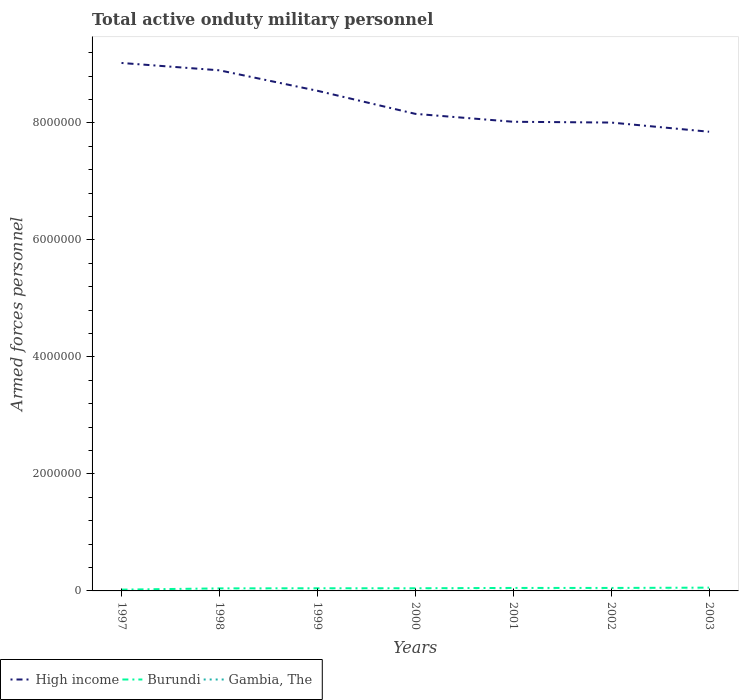How many different coloured lines are there?
Your response must be concise. 3. Does the line corresponding to Gambia, The intersect with the line corresponding to Burundi?
Give a very brief answer. No. Across all years, what is the maximum number of armed forces personnel in Gambia, The?
Offer a very short reply. 800. What is the total number of armed forces personnel in Burundi in the graph?
Give a very brief answer. -3.40e+04. What is the difference between the highest and the second highest number of armed forces personnel in Gambia, The?
Offer a terse response. 0. How many lines are there?
Provide a short and direct response. 3. How many years are there in the graph?
Give a very brief answer. 7. How many legend labels are there?
Your answer should be compact. 3. How are the legend labels stacked?
Your answer should be very brief. Horizontal. What is the title of the graph?
Offer a very short reply. Total active onduty military personnel. Does "Venezuela" appear as one of the legend labels in the graph?
Your response must be concise. No. What is the label or title of the Y-axis?
Give a very brief answer. Armed forces personnel. What is the Armed forces personnel in High income in 1997?
Make the answer very short. 9.03e+06. What is the Armed forces personnel in Burundi in 1997?
Your answer should be compact. 2.20e+04. What is the Armed forces personnel in Gambia, The in 1997?
Make the answer very short. 800. What is the Armed forces personnel of High income in 1998?
Provide a short and direct response. 8.90e+06. What is the Armed forces personnel of Burundi in 1998?
Your response must be concise. 4.35e+04. What is the Armed forces personnel of Gambia, The in 1998?
Give a very brief answer. 800. What is the Armed forces personnel in High income in 1999?
Your answer should be very brief. 8.55e+06. What is the Armed forces personnel in Burundi in 1999?
Offer a terse response. 4.55e+04. What is the Armed forces personnel of Gambia, The in 1999?
Your answer should be very brief. 800. What is the Armed forces personnel of High income in 2000?
Ensure brevity in your answer.  8.16e+06. What is the Armed forces personnel in Burundi in 2000?
Your answer should be compact. 4.55e+04. What is the Armed forces personnel of Gambia, The in 2000?
Your response must be concise. 800. What is the Armed forces personnel of High income in 2001?
Your answer should be compact. 8.02e+06. What is the Armed forces personnel of Burundi in 2001?
Offer a very short reply. 5.10e+04. What is the Armed forces personnel in Gambia, The in 2001?
Your answer should be very brief. 800. What is the Armed forces personnel of High income in 2002?
Make the answer very short. 8.01e+06. What is the Armed forces personnel in Burundi in 2002?
Your answer should be compact. 5.10e+04. What is the Armed forces personnel in Gambia, The in 2002?
Your response must be concise. 800. What is the Armed forces personnel of High income in 2003?
Keep it short and to the point. 7.85e+06. What is the Armed forces personnel in Burundi in 2003?
Keep it short and to the point. 5.60e+04. What is the Armed forces personnel of Gambia, The in 2003?
Your response must be concise. 800. Across all years, what is the maximum Armed forces personnel of High income?
Offer a very short reply. 9.03e+06. Across all years, what is the maximum Armed forces personnel of Burundi?
Offer a terse response. 5.60e+04. Across all years, what is the maximum Armed forces personnel of Gambia, The?
Provide a succinct answer. 800. Across all years, what is the minimum Armed forces personnel of High income?
Your answer should be very brief. 7.85e+06. Across all years, what is the minimum Armed forces personnel of Burundi?
Keep it short and to the point. 2.20e+04. Across all years, what is the minimum Armed forces personnel of Gambia, The?
Your answer should be very brief. 800. What is the total Armed forces personnel of High income in the graph?
Your answer should be very brief. 5.85e+07. What is the total Armed forces personnel of Burundi in the graph?
Give a very brief answer. 3.14e+05. What is the total Armed forces personnel in Gambia, The in the graph?
Offer a very short reply. 5600. What is the difference between the Armed forces personnel of High income in 1997 and that in 1998?
Make the answer very short. 1.26e+05. What is the difference between the Armed forces personnel in Burundi in 1997 and that in 1998?
Make the answer very short. -2.15e+04. What is the difference between the Armed forces personnel in Gambia, The in 1997 and that in 1998?
Offer a very short reply. 0. What is the difference between the Armed forces personnel in High income in 1997 and that in 1999?
Your response must be concise. 4.75e+05. What is the difference between the Armed forces personnel in Burundi in 1997 and that in 1999?
Offer a terse response. -2.35e+04. What is the difference between the Armed forces personnel of High income in 1997 and that in 2000?
Your answer should be compact. 8.70e+05. What is the difference between the Armed forces personnel of Burundi in 1997 and that in 2000?
Ensure brevity in your answer.  -2.35e+04. What is the difference between the Armed forces personnel of Gambia, The in 1997 and that in 2000?
Keep it short and to the point. 0. What is the difference between the Armed forces personnel of High income in 1997 and that in 2001?
Your response must be concise. 1.01e+06. What is the difference between the Armed forces personnel of Burundi in 1997 and that in 2001?
Ensure brevity in your answer.  -2.90e+04. What is the difference between the Armed forces personnel in Gambia, The in 1997 and that in 2001?
Make the answer very short. 0. What is the difference between the Armed forces personnel of High income in 1997 and that in 2002?
Provide a succinct answer. 1.02e+06. What is the difference between the Armed forces personnel of Burundi in 1997 and that in 2002?
Provide a succinct answer. -2.90e+04. What is the difference between the Armed forces personnel of High income in 1997 and that in 2003?
Offer a terse response. 1.18e+06. What is the difference between the Armed forces personnel in Burundi in 1997 and that in 2003?
Your answer should be compact. -3.40e+04. What is the difference between the Armed forces personnel in High income in 1998 and that in 1999?
Ensure brevity in your answer.  3.50e+05. What is the difference between the Armed forces personnel in Burundi in 1998 and that in 1999?
Provide a short and direct response. -2000. What is the difference between the Armed forces personnel of High income in 1998 and that in 2000?
Ensure brevity in your answer.  7.44e+05. What is the difference between the Armed forces personnel in Burundi in 1998 and that in 2000?
Your response must be concise. -2000. What is the difference between the Armed forces personnel of High income in 1998 and that in 2001?
Give a very brief answer. 8.79e+05. What is the difference between the Armed forces personnel in Burundi in 1998 and that in 2001?
Offer a very short reply. -7500. What is the difference between the Armed forces personnel in Gambia, The in 1998 and that in 2001?
Offer a very short reply. 0. What is the difference between the Armed forces personnel of High income in 1998 and that in 2002?
Offer a terse response. 8.93e+05. What is the difference between the Armed forces personnel of Burundi in 1998 and that in 2002?
Give a very brief answer. -7500. What is the difference between the Armed forces personnel of High income in 1998 and that in 2003?
Give a very brief answer. 1.05e+06. What is the difference between the Armed forces personnel in Burundi in 1998 and that in 2003?
Provide a succinct answer. -1.25e+04. What is the difference between the Armed forces personnel in High income in 1999 and that in 2000?
Keep it short and to the point. 3.95e+05. What is the difference between the Armed forces personnel in Burundi in 1999 and that in 2000?
Make the answer very short. 0. What is the difference between the Armed forces personnel of Gambia, The in 1999 and that in 2000?
Offer a very short reply. 0. What is the difference between the Armed forces personnel of High income in 1999 and that in 2001?
Your answer should be compact. 5.30e+05. What is the difference between the Armed forces personnel of Burundi in 1999 and that in 2001?
Offer a very short reply. -5500. What is the difference between the Armed forces personnel in High income in 1999 and that in 2002?
Your answer should be compact. 5.43e+05. What is the difference between the Armed forces personnel of Burundi in 1999 and that in 2002?
Offer a very short reply. -5500. What is the difference between the Armed forces personnel in High income in 1999 and that in 2003?
Give a very brief answer. 7.00e+05. What is the difference between the Armed forces personnel of Burundi in 1999 and that in 2003?
Offer a very short reply. -1.05e+04. What is the difference between the Armed forces personnel in Gambia, The in 1999 and that in 2003?
Offer a terse response. 0. What is the difference between the Armed forces personnel of High income in 2000 and that in 2001?
Keep it short and to the point. 1.35e+05. What is the difference between the Armed forces personnel in Burundi in 2000 and that in 2001?
Make the answer very short. -5500. What is the difference between the Armed forces personnel in High income in 2000 and that in 2002?
Your response must be concise. 1.49e+05. What is the difference between the Armed forces personnel of Burundi in 2000 and that in 2002?
Give a very brief answer. -5500. What is the difference between the Armed forces personnel in Gambia, The in 2000 and that in 2002?
Offer a very short reply. 0. What is the difference between the Armed forces personnel in High income in 2000 and that in 2003?
Give a very brief answer. 3.06e+05. What is the difference between the Armed forces personnel of Burundi in 2000 and that in 2003?
Your answer should be very brief. -1.05e+04. What is the difference between the Armed forces personnel of Gambia, The in 2000 and that in 2003?
Keep it short and to the point. 0. What is the difference between the Armed forces personnel in High income in 2001 and that in 2002?
Provide a succinct answer. 1.36e+04. What is the difference between the Armed forces personnel in Burundi in 2001 and that in 2002?
Provide a succinct answer. 0. What is the difference between the Armed forces personnel of Gambia, The in 2001 and that in 2002?
Offer a very short reply. 0. What is the difference between the Armed forces personnel in High income in 2001 and that in 2003?
Ensure brevity in your answer.  1.70e+05. What is the difference between the Armed forces personnel of Burundi in 2001 and that in 2003?
Your answer should be compact. -5000. What is the difference between the Armed forces personnel of High income in 2002 and that in 2003?
Your response must be concise. 1.57e+05. What is the difference between the Armed forces personnel of Burundi in 2002 and that in 2003?
Your answer should be very brief. -5000. What is the difference between the Armed forces personnel of Gambia, The in 2002 and that in 2003?
Your answer should be very brief. 0. What is the difference between the Armed forces personnel in High income in 1997 and the Armed forces personnel in Burundi in 1998?
Your answer should be compact. 8.98e+06. What is the difference between the Armed forces personnel of High income in 1997 and the Armed forces personnel of Gambia, The in 1998?
Ensure brevity in your answer.  9.02e+06. What is the difference between the Armed forces personnel in Burundi in 1997 and the Armed forces personnel in Gambia, The in 1998?
Make the answer very short. 2.12e+04. What is the difference between the Armed forces personnel in High income in 1997 and the Armed forces personnel in Burundi in 1999?
Your response must be concise. 8.98e+06. What is the difference between the Armed forces personnel in High income in 1997 and the Armed forces personnel in Gambia, The in 1999?
Your answer should be compact. 9.02e+06. What is the difference between the Armed forces personnel in Burundi in 1997 and the Armed forces personnel in Gambia, The in 1999?
Offer a terse response. 2.12e+04. What is the difference between the Armed forces personnel in High income in 1997 and the Armed forces personnel in Burundi in 2000?
Give a very brief answer. 8.98e+06. What is the difference between the Armed forces personnel in High income in 1997 and the Armed forces personnel in Gambia, The in 2000?
Offer a terse response. 9.02e+06. What is the difference between the Armed forces personnel in Burundi in 1997 and the Armed forces personnel in Gambia, The in 2000?
Offer a very short reply. 2.12e+04. What is the difference between the Armed forces personnel in High income in 1997 and the Armed forces personnel in Burundi in 2001?
Keep it short and to the point. 8.97e+06. What is the difference between the Armed forces personnel of High income in 1997 and the Armed forces personnel of Gambia, The in 2001?
Your answer should be very brief. 9.02e+06. What is the difference between the Armed forces personnel in Burundi in 1997 and the Armed forces personnel in Gambia, The in 2001?
Give a very brief answer. 2.12e+04. What is the difference between the Armed forces personnel of High income in 1997 and the Armed forces personnel of Burundi in 2002?
Provide a succinct answer. 8.97e+06. What is the difference between the Armed forces personnel of High income in 1997 and the Armed forces personnel of Gambia, The in 2002?
Ensure brevity in your answer.  9.02e+06. What is the difference between the Armed forces personnel of Burundi in 1997 and the Armed forces personnel of Gambia, The in 2002?
Your answer should be compact. 2.12e+04. What is the difference between the Armed forces personnel of High income in 1997 and the Armed forces personnel of Burundi in 2003?
Ensure brevity in your answer.  8.97e+06. What is the difference between the Armed forces personnel in High income in 1997 and the Armed forces personnel in Gambia, The in 2003?
Give a very brief answer. 9.02e+06. What is the difference between the Armed forces personnel in Burundi in 1997 and the Armed forces personnel in Gambia, The in 2003?
Your answer should be compact. 2.12e+04. What is the difference between the Armed forces personnel of High income in 1998 and the Armed forces personnel of Burundi in 1999?
Keep it short and to the point. 8.85e+06. What is the difference between the Armed forces personnel in High income in 1998 and the Armed forces personnel in Gambia, The in 1999?
Your answer should be compact. 8.90e+06. What is the difference between the Armed forces personnel of Burundi in 1998 and the Armed forces personnel of Gambia, The in 1999?
Make the answer very short. 4.27e+04. What is the difference between the Armed forces personnel of High income in 1998 and the Armed forces personnel of Burundi in 2000?
Provide a short and direct response. 8.85e+06. What is the difference between the Armed forces personnel of High income in 1998 and the Armed forces personnel of Gambia, The in 2000?
Provide a succinct answer. 8.90e+06. What is the difference between the Armed forces personnel in Burundi in 1998 and the Armed forces personnel in Gambia, The in 2000?
Ensure brevity in your answer.  4.27e+04. What is the difference between the Armed forces personnel in High income in 1998 and the Armed forces personnel in Burundi in 2001?
Offer a very short reply. 8.85e+06. What is the difference between the Armed forces personnel in High income in 1998 and the Armed forces personnel in Gambia, The in 2001?
Ensure brevity in your answer.  8.90e+06. What is the difference between the Armed forces personnel in Burundi in 1998 and the Armed forces personnel in Gambia, The in 2001?
Make the answer very short. 4.27e+04. What is the difference between the Armed forces personnel of High income in 1998 and the Armed forces personnel of Burundi in 2002?
Provide a succinct answer. 8.85e+06. What is the difference between the Armed forces personnel of High income in 1998 and the Armed forces personnel of Gambia, The in 2002?
Give a very brief answer. 8.90e+06. What is the difference between the Armed forces personnel in Burundi in 1998 and the Armed forces personnel in Gambia, The in 2002?
Your response must be concise. 4.27e+04. What is the difference between the Armed forces personnel in High income in 1998 and the Armed forces personnel in Burundi in 2003?
Ensure brevity in your answer.  8.84e+06. What is the difference between the Armed forces personnel of High income in 1998 and the Armed forces personnel of Gambia, The in 2003?
Offer a very short reply. 8.90e+06. What is the difference between the Armed forces personnel of Burundi in 1998 and the Armed forces personnel of Gambia, The in 2003?
Give a very brief answer. 4.27e+04. What is the difference between the Armed forces personnel of High income in 1999 and the Armed forces personnel of Burundi in 2000?
Give a very brief answer. 8.50e+06. What is the difference between the Armed forces personnel in High income in 1999 and the Armed forces personnel in Gambia, The in 2000?
Offer a terse response. 8.55e+06. What is the difference between the Armed forces personnel in Burundi in 1999 and the Armed forces personnel in Gambia, The in 2000?
Keep it short and to the point. 4.47e+04. What is the difference between the Armed forces personnel in High income in 1999 and the Armed forces personnel in Burundi in 2001?
Make the answer very short. 8.50e+06. What is the difference between the Armed forces personnel of High income in 1999 and the Armed forces personnel of Gambia, The in 2001?
Your response must be concise. 8.55e+06. What is the difference between the Armed forces personnel in Burundi in 1999 and the Armed forces personnel in Gambia, The in 2001?
Offer a terse response. 4.47e+04. What is the difference between the Armed forces personnel in High income in 1999 and the Armed forces personnel in Burundi in 2002?
Make the answer very short. 8.50e+06. What is the difference between the Armed forces personnel in High income in 1999 and the Armed forces personnel in Gambia, The in 2002?
Your answer should be compact. 8.55e+06. What is the difference between the Armed forces personnel in Burundi in 1999 and the Armed forces personnel in Gambia, The in 2002?
Provide a short and direct response. 4.47e+04. What is the difference between the Armed forces personnel in High income in 1999 and the Armed forces personnel in Burundi in 2003?
Ensure brevity in your answer.  8.49e+06. What is the difference between the Armed forces personnel of High income in 1999 and the Armed forces personnel of Gambia, The in 2003?
Offer a very short reply. 8.55e+06. What is the difference between the Armed forces personnel of Burundi in 1999 and the Armed forces personnel of Gambia, The in 2003?
Keep it short and to the point. 4.47e+04. What is the difference between the Armed forces personnel of High income in 2000 and the Armed forces personnel of Burundi in 2001?
Make the answer very short. 8.10e+06. What is the difference between the Armed forces personnel of High income in 2000 and the Armed forces personnel of Gambia, The in 2001?
Provide a succinct answer. 8.15e+06. What is the difference between the Armed forces personnel in Burundi in 2000 and the Armed forces personnel in Gambia, The in 2001?
Your answer should be compact. 4.47e+04. What is the difference between the Armed forces personnel in High income in 2000 and the Armed forces personnel in Burundi in 2002?
Keep it short and to the point. 8.10e+06. What is the difference between the Armed forces personnel of High income in 2000 and the Armed forces personnel of Gambia, The in 2002?
Provide a short and direct response. 8.15e+06. What is the difference between the Armed forces personnel of Burundi in 2000 and the Armed forces personnel of Gambia, The in 2002?
Your answer should be very brief. 4.47e+04. What is the difference between the Armed forces personnel in High income in 2000 and the Armed forces personnel in Burundi in 2003?
Provide a short and direct response. 8.10e+06. What is the difference between the Armed forces personnel of High income in 2000 and the Armed forces personnel of Gambia, The in 2003?
Your answer should be compact. 8.15e+06. What is the difference between the Armed forces personnel of Burundi in 2000 and the Armed forces personnel of Gambia, The in 2003?
Offer a very short reply. 4.47e+04. What is the difference between the Armed forces personnel of High income in 2001 and the Armed forces personnel of Burundi in 2002?
Your answer should be compact. 7.97e+06. What is the difference between the Armed forces personnel of High income in 2001 and the Armed forces personnel of Gambia, The in 2002?
Offer a very short reply. 8.02e+06. What is the difference between the Armed forces personnel of Burundi in 2001 and the Armed forces personnel of Gambia, The in 2002?
Ensure brevity in your answer.  5.02e+04. What is the difference between the Armed forces personnel in High income in 2001 and the Armed forces personnel in Burundi in 2003?
Provide a succinct answer. 7.96e+06. What is the difference between the Armed forces personnel of High income in 2001 and the Armed forces personnel of Gambia, The in 2003?
Offer a terse response. 8.02e+06. What is the difference between the Armed forces personnel in Burundi in 2001 and the Armed forces personnel in Gambia, The in 2003?
Provide a short and direct response. 5.02e+04. What is the difference between the Armed forces personnel in High income in 2002 and the Armed forces personnel in Burundi in 2003?
Provide a short and direct response. 7.95e+06. What is the difference between the Armed forces personnel in High income in 2002 and the Armed forces personnel in Gambia, The in 2003?
Your answer should be very brief. 8.01e+06. What is the difference between the Armed forces personnel in Burundi in 2002 and the Armed forces personnel in Gambia, The in 2003?
Ensure brevity in your answer.  5.02e+04. What is the average Armed forces personnel in High income per year?
Your answer should be compact. 8.36e+06. What is the average Armed forces personnel in Burundi per year?
Offer a terse response. 4.49e+04. What is the average Armed forces personnel of Gambia, The per year?
Give a very brief answer. 800. In the year 1997, what is the difference between the Armed forces personnel of High income and Armed forces personnel of Burundi?
Provide a succinct answer. 9.00e+06. In the year 1997, what is the difference between the Armed forces personnel of High income and Armed forces personnel of Gambia, The?
Your answer should be compact. 9.02e+06. In the year 1997, what is the difference between the Armed forces personnel of Burundi and Armed forces personnel of Gambia, The?
Your answer should be very brief. 2.12e+04. In the year 1998, what is the difference between the Armed forces personnel of High income and Armed forces personnel of Burundi?
Make the answer very short. 8.86e+06. In the year 1998, what is the difference between the Armed forces personnel in High income and Armed forces personnel in Gambia, The?
Ensure brevity in your answer.  8.90e+06. In the year 1998, what is the difference between the Armed forces personnel in Burundi and Armed forces personnel in Gambia, The?
Ensure brevity in your answer.  4.27e+04. In the year 1999, what is the difference between the Armed forces personnel in High income and Armed forces personnel in Burundi?
Give a very brief answer. 8.50e+06. In the year 1999, what is the difference between the Armed forces personnel of High income and Armed forces personnel of Gambia, The?
Your answer should be compact. 8.55e+06. In the year 1999, what is the difference between the Armed forces personnel in Burundi and Armed forces personnel in Gambia, The?
Offer a terse response. 4.47e+04. In the year 2000, what is the difference between the Armed forces personnel in High income and Armed forces personnel in Burundi?
Make the answer very short. 8.11e+06. In the year 2000, what is the difference between the Armed forces personnel of High income and Armed forces personnel of Gambia, The?
Your answer should be very brief. 8.15e+06. In the year 2000, what is the difference between the Armed forces personnel in Burundi and Armed forces personnel in Gambia, The?
Ensure brevity in your answer.  4.47e+04. In the year 2001, what is the difference between the Armed forces personnel of High income and Armed forces personnel of Burundi?
Offer a terse response. 7.97e+06. In the year 2001, what is the difference between the Armed forces personnel in High income and Armed forces personnel in Gambia, The?
Your response must be concise. 8.02e+06. In the year 2001, what is the difference between the Armed forces personnel of Burundi and Armed forces personnel of Gambia, The?
Your answer should be very brief. 5.02e+04. In the year 2002, what is the difference between the Armed forces personnel in High income and Armed forces personnel in Burundi?
Your answer should be compact. 7.96e+06. In the year 2002, what is the difference between the Armed forces personnel of High income and Armed forces personnel of Gambia, The?
Provide a short and direct response. 8.01e+06. In the year 2002, what is the difference between the Armed forces personnel in Burundi and Armed forces personnel in Gambia, The?
Provide a succinct answer. 5.02e+04. In the year 2003, what is the difference between the Armed forces personnel of High income and Armed forces personnel of Burundi?
Offer a terse response. 7.79e+06. In the year 2003, what is the difference between the Armed forces personnel of High income and Armed forces personnel of Gambia, The?
Keep it short and to the point. 7.85e+06. In the year 2003, what is the difference between the Armed forces personnel in Burundi and Armed forces personnel in Gambia, The?
Make the answer very short. 5.52e+04. What is the ratio of the Armed forces personnel of High income in 1997 to that in 1998?
Offer a terse response. 1.01. What is the ratio of the Armed forces personnel in Burundi in 1997 to that in 1998?
Offer a very short reply. 0.51. What is the ratio of the Armed forces personnel of Gambia, The in 1997 to that in 1998?
Give a very brief answer. 1. What is the ratio of the Armed forces personnel of High income in 1997 to that in 1999?
Offer a very short reply. 1.06. What is the ratio of the Armed forces personnel of Burundi in 1997 to that in 1999?
Provide a succinct answer. 0.48. What is the ratio of the Armed forces personnel of High income in 1997 to that in 2000?
Provide a succinct answer. 1.11. What is the ratio of the Armed forces personnel of Burundi in 1997 to that in 2000?
Make the answer very short. 0.48. What is the ratio of the Armed forces personnel of Gambia, The in 1997 to that in 2000?
Keep it short and to the point. 1. What is the ratio of the Armed forces personnel of High income in 1997 to that in 2001?
Ensure brevity in your answer.  1.13. What is the ratio of the Armed forces personnel in Burundi in 1997 to that in 2001?
Provide a short and direct response. 0.43. What is the ratio of the Armed forces personnel of Gambia, The in 1997 to that in 2001?
Offer a very short reply. 1. What is the ratio of the Armed forces personnel in High income in 1997 to that in 2002?
Provide a short and direct response. 1.13. What is the ratio of the Armed forces personnel in Burundi in 1997 to that in 2002?
Keep it short and to the point. 0.43. What is the ratio of the Armed forces personnel of Gambia, The in 1997 to that in 2002?
Offer a very short reply. 1. What is the ratio of the Armed forces personnel in High income in 1997 to that in 2003?
Your answer should be very brief. 1.15. What is the ratio of the Armed forces personnel in Burundi in 1997 to that in 2003?
Your response must be concise. 0.39. What is the ratio of the Armed forces personnel in High income in 1998 to that in 1999?
Provide a short and direct response. 1.04. What is the ratio of the Armed forces personnel in Burundi in 1998 to that in 1999?
Make the answer very short. 0.96. What is the ratio of the Armed forces personnel of High income in 1998 to that in 2000?
Keep it short and to the point. 1.09. What is the ratio of the Armed forces personnel in Burundi in 1998 to that in 2000?
Your answer should be compact. 0.96. What is the ratio of the Armed forces personnel of High income in 1998 to that in 2001?
Provide a succinct answer. 1.11. What is the ratio of the Armed forces personnel in Burundi in 1998 to that in 2001?
Your answer should be compact. 0.85. What is the ratio of the Armed forces personnel of High income in 1998 to that in 2002?
Your answer should be compact. 1.11. What is the ratio of the Armed forces personnel in Burundi in 1998 to that in 2002?
Your answer should be compact. 0.85. What is the ratio of the Armed forces personnel in Gambia, The in 1998 to that in 2002?
Make the answer very short. 1. What is the ratio of the Armed forces personnel in High income in 1998 to that in 2003?
Make the answer very short. 1.13. What is the ratio of the Armed forces personnel in Burundi in 1998 to that in 2003?
Give a very brief answer. 0.78. What is the ratio of the Armed forces personnel of High income in 1999 to that in 2000?
Your response must be concise. 1.05. What is the ratio of the Armed forces personnel in Burundi in 1999 to that in 2000?
Give a very brief answer. 1. What is the ratio of the Armed forces personnel of Gambia, The in 1999 to that in 2000?
Ensure brevity in your answer.  1. What is the ratio of the Armed forces personnel in High income in 1999 to that in 2001?
Your answer should be compact. 1.07. What is the ratio of the Armed forces personnel in Burundi in 1999 to that in 2001?
Give a very brief answer. 0.89. What is the ratio of the Armed forces personnel of High income in 1999 to that in 2002?
Offer a terse response. 1.07. What is the ratio of the Armed forces personnel in Burundi in 1999 to that in 2002?
Make the answer very short. 0.89. What is the ratio of the Armed forces personnel of Gambia, The in 1999 to that in 2002?
Offer a very short reply. 1. What is the ratio of the Armed forces personnel in High income in 1999 to that in 2003?
Ensure brevity in your answer.  1.09. What is the ratio of the Armed forces personnel in Burundi in 1999 to that in 2003?
Your answer should be compact. 0.81. What is the ratio of the Armed forces personnel in High income in 2000 to that in 2001?
Your answer should be compact. 1.02. What is the ratio of the Armed forces personnel of Burundi in 2000 to that in 2001?
Offer a very short reply. 0.89. What is the ratio of the Armed forces personnel in High income in 2000 to that in 2002?
Offer a very short reply. 1.02. What is the ratio of the Armed forces personnel in Burundi in 2000 to that in 2002?
Your response must be concise. 0.89. What is the ratio of the Armed forces personnel of High income in 2000 to that in 2003?
Ensure brevity in your answer.  1.04. What is the ratio of the Armed forces personnel of Burundi in 2000 to that in 2003?
Offer a terse response. 0.81. What is the ratio of the Armed forces personnel of Gambia, The in 2000 to that in 2003?
Make the answer very short. 1. What is the ratio of the Armed forces personnel in High income in 2001 to that in 2002?
Offer a terse response. 1. What is the ratio of the Armed forces personnel in High income in 2001 to that in 2003?
Provide a succinct answer. 1.02. What is the ratio of the Armed forces personnel of Burundi in 2001 to that in 2003?
Ensure brevity in your answer.  0.91. What is the ratio of the Armed forces personnel of Burundi in 2002 to that in 2003?
Your response must be concise. 0.91. What is the ratio of the Armed forces personnel of Gambia, The in 2002 to that in 2003?
Keep it short and to the point. 1. What is the difference between the highest and the second highest Armed forces personnel in High income?
Your answer should be compact. 1.26e+05. What is the difference between the highest and the second highest Armed forces personnel of Burundi?
Provide a short and direct response. 5000. What is the difference between the highest and the lowest Armed forces personnel of High income?
Provide a succinct answer. 1.18e+06. What is the difference between the highest and the lowest Armed forces personnel of Burundi?
Ensure brevity in your answer.  3.40e+04. What is the difference between the highest and the lowest Armed forces personnel in Gambia, The?
Your response must be concise. 0. 